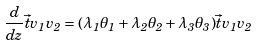<formula> <loc_0><loc_0><loc_500><loc_500>\frac { d } { d z } \vec { t } { v _ { 1 } } { v _ { 2 } } = ( \lambda _ { 1 } \theta _ { 1 } + \lambda _ { 2 } \theta _ { 2 } + \lambda _ { 3 } \theta _ { 3 } ) \vec { t } { v _ { 1 } } { v _ { 2 } }</formula> 